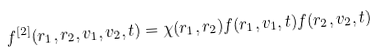Convert formula to latex. <formula><loc_0><loc_0><loc_500><loc_500>f ^ { [ 2 ] } ( { r _ { 1 } } , { r _ { 2 } } , { v _ { 1 } } , { v _ { 2 } } , t ) = \chi ( { r _ { 1 } } , { r _ { 2 } } ) f ( { r _ { 1 } } , { v _ { 1 } } , t ) f ( { r _ { 2 } } , { v _ { 2 } } , t )</formula> 